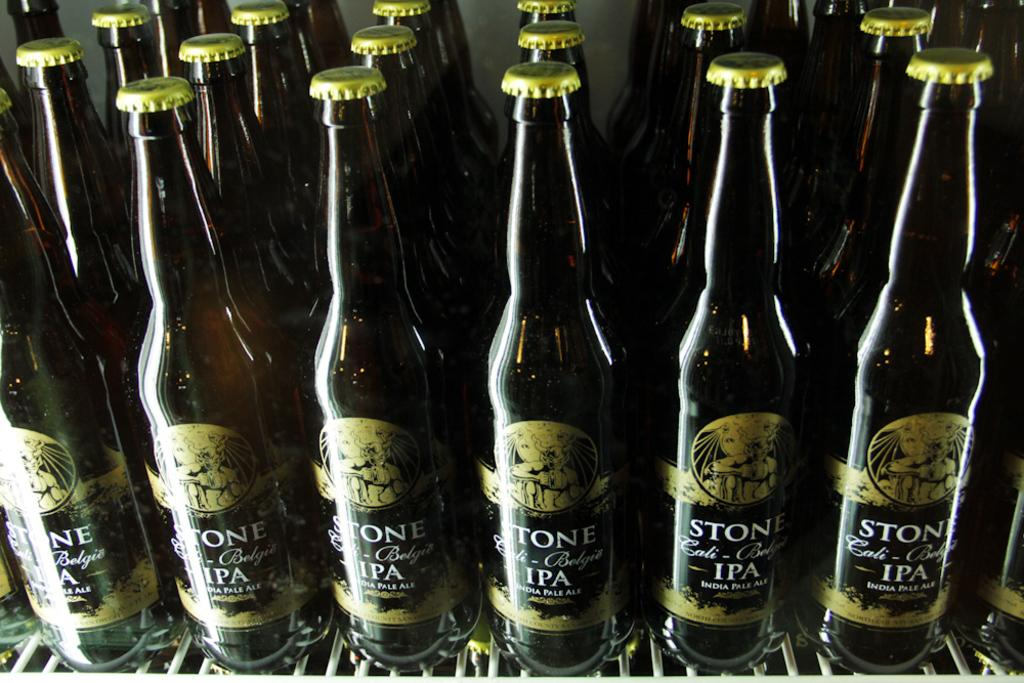What is the primary subject of the image? The primary subject of the image is many bottles. What can be found inside the bottles? The bottles contain liquid. How many cows are present in the image? There are no cows present in the image; the image only features bottles containing liquid. What type of stew is being prepared in the image? There is no stew or cooking activity depicted in the image. 